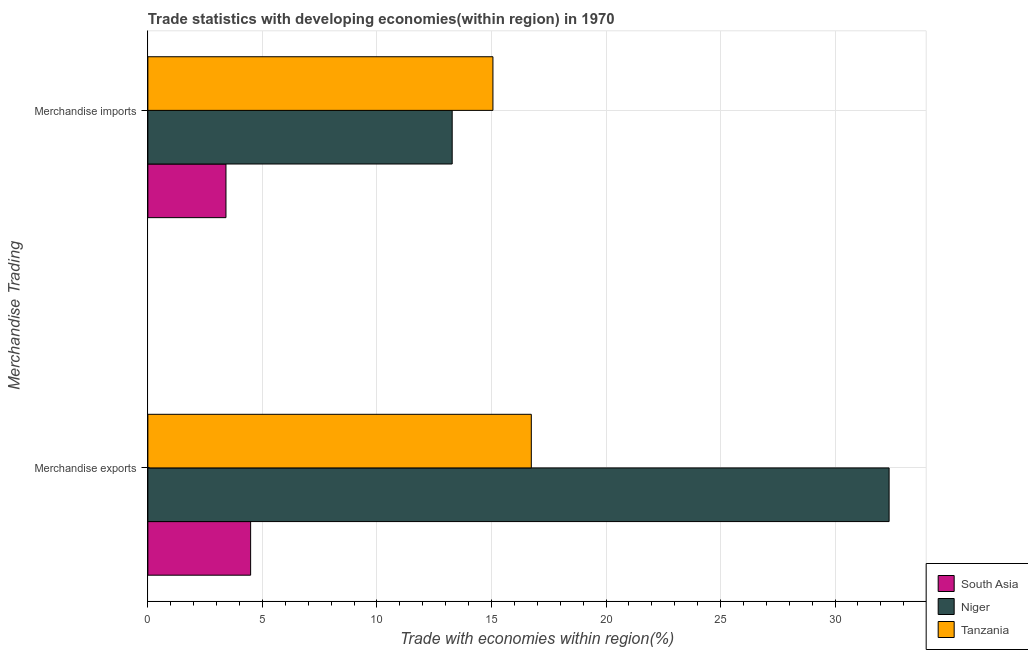How many different coloured bars are there?
Offer a very short reply. 3. How many groups of bars are there?
Offer a very short reply. 2. Are the number of bars per tick equal to the number of legend labels?
Ensure brevity in your answer.  Yes. Are the number of bars on each tick of the Y-axis equal?
Ensure brevity in your answer.  Yes. How many bars are there on the 2nd tick from the top?
Keep it short and to the point. 3. How many bars are there on the 1st tick from the bottom?
Provide a succinct answer. 3. What is the merchandise imports in Niger?
Offer a terse response. 13.29. Across all countries, what is the maximum merchandise imports?
Provide a short and direct response. 15.06. Across all countries, what is the minimum merchandise imports?
Offer a very short reply. 3.41. In which country was the merchandise imports maximum?
Your answer should be compact. Tanzania. In which country was the merchandise imports minimum?
Provide a short and direct response. South Asia. What is the total merchandise exports in the graph?
Your response must be concise. 53.58. What is the difference between the merchandise imports in Tanzania and that in South Asia?
Offer a very short reply. 11.65. What is the difference between the merchandise imports in South Asia and the merchandise exports in Niger?
Your answer should be compact. -28.95. What is the average merchandise imports per country?
Offer a terse response. 10.59. What is the difference between the merchandise imports and merchandise exports in South Asia?
Your answer should be very brief. -1.08. What is the ratio of the merchandise exports in Tanzania to that in South Asia?
Give a very brief answer. 3.73. In how many countries, is the merchandise imports greater than the average merchandise imports taken over all countries?
Your response must be concise. 2. What does the 3rd bar from the top in Merchandise imports represents?
Provide a short and direct response. South Asia. What does the 3rd bar from the bottom in Merchandise imports represents?
Your answer should be very brief. Tanzania. How many bars are there?
Offer a terse response. 6. How many countries are there in the graph?
Provide a short and direct response. 3. Does the graph contain any zero values?
Your answer should be very brief. No. Does the graph contain grids?
Offer a very short reply. Yes. How many legend labels are there?
Keep it short and to the point. 3. What is the title of the graph?
Provide a short and direct response. Trade statistics with developing economies(within region) in 1970. Does "Bahrain" appear as one of the legend labels in the graph?
Offer a terse response. No. What is the label or title of the X-axis?
Make the answer very short. Trade with economies within region(%). What is the label or title of the Y-axis?
Provide a short and direct response. Merchandise Trading. What is the Trade with economies within region(%) in South Asia in Merchandise exports?
Keep it short and to the point. 4.49. What is the Trade with economies within region(%) in Niger in Merchandise exports?
Make the answer very short. 32.36. What is the Trade with economies within region(%) in Tanzania in Merchandise exports?
Your response must be concise. 16.74. What is the Trade with economies within region(%) of South Asia in Merchandise imports?
Your response must be concise. 3.41. What is the Trade with economies within region(%) in Niger in Merchandise imports?
Provide a succinct answer. 13.29. What is the Trade with economies within region(%) in Tanzania in Merchandise imports?
Keep it short and to the point. 15.06. Across all Merchandise Trading, what is the maximum Trade with economies within region(%) in South Asia?
Provide a short and direct response. 4.49. Across all Merchandise Trading, what is the maximum Trade with economies within region(%) of Niger?
Provide a succinct answer. 32.36. Across all Merchandise Trading, what is the maximum Trade with economies within region(%) in Tanzania?
Provide a succinct answer. 16.74. Across all Merchandise Trading, what is the minimum Trade with economies within region(%) in South Asia?
Your answer should be compact. 3.41. Across all Merchandise Trading, what is the minimum Trade with economies within region(%) of Niger?
Offer a terse response. 13.29. Across all Merchandise Trading, what is the minimum Trade with economies within region(%) of Tanzania?
Make the answer very short. 15.06. What is the total Trade with economies within region(%) in South Asia in the graph?
Your answer should be compact. 7.9. What is the total Trade with economies within region(%) in Niger in the graph?
Give a very brief answer. 45.64. What is the total Trade with economies within region(%) of Tanzania in the graph?
Provide a short and direct response. 31.8. What is the difference between the Trade with economies within region(%) of South Asia in Merchandise exports and that in Merchandise imports?
Your response must be concise. 1.08. What is the difference between the Trade with economies within region(%) of Niger in Merchandise exports and that in Merchandise imports?
Make the answer very short. 19.07. What is the difference between the Trade with economies within region(%) of Tanzania in Merchandise exports and that in Merchandise imports?
Make the answer very short. 1.68. What is the difference between the Trade with economies within region(%) of South Asia in Merchandise exports and the Trade with economies within region(%) of Niger in Merchandise imports?
Offer a very short reply. -8.8. What is the difference between the Trade with economies within region(%) of South Asia in Merchandise exports and the Trade with economies within region(%) of Tanzania in Merchandise imports?
Your answer should be very brief. -10.58. What is the difference between the Trade with economies within region(%) of Niger in Merchandise exports and the Trade with economies within region(%) of Tanzania in Merchandise imports?
Provide a short and direct response. 17.29. What is the average Trade with economies within region(%) of South Asia per Merchandise Trading?
Give a very brief answer. 3.95. What is the average Trade with economies within region(%) of Niger per Merchandise Trading?
Your answer should be very brief. 22.82. What is the average Trade with economies within region(%) of Tanzania per Merchandise Trading?
Provide a short and direct response. 15.9. What is the difference between the Trade with economies within region(%) of South Asia and Trade with economies within region(%) of Niger in Merchandise exports?
Your response must be concise. -27.87. What is the difference between the Trade with economies within region(%) in South Asia and Trade with economies within region(%) in Tanzania in Merchandise exports?
Provide a succinct answer. -12.25. What is the difference between the Trade with economies within region(%) in Niger and Trade with economies within region(%) in Tanzania in Merchandise exports?
Give a very brief answer. 15.62. What is the difference between the Trade with economies within region(%) of South Asia and Trade with economies within region(%) of Niger in Merchandise imports?
Your response must be concise. -9.88. What is the difference between the Trade with economies within region(%) in South Asia and Trade with economies within region(%) in Tanzania in Merchandise imports?
Provide a succinct answer. -11.65. What is the difference between the Trade with economies within region(%) in Niger and Trade with economies within region(%) in Tanzania in Merchandise imports?
Give a very brief answer. -1.78. What is the ratio of the Trade with economies within region(%) in South Asia in Merchandise exports to that in Merchandise imports?
Keep it short and to the point. 1.32. What is the ratio of the Trade with economies within region(%) of Niger in Merchandise exports to that in Merchandise imports?
Your answer should be compact. 2.44. What is the ratio of the Trade with economies within region(%) of Tanzania in Merchandise exports to that in Merchandise imports?
Make the answer very short. 1.11. What is the difference between the highest and the second highest Trade with economies within region(%) of South Asia?
Offer a very short reply. 1.08. What is the difference between the highest and the second highest Trade with economies within region(%) in Niger?
Offer a very short reply. 19.07. What is the difference between the highest and the second highest Trade with economies within region(%) of Tanzania?
Your answer should be very brief. 1.68. What is the difference between the highest and the lowest Trade with economies within region(%) of South Asia?
Provide a succinct answer. 1.08. What is the difference between the highest and the lowest Trade with economies within region(%) in Niger?
Keep it short and to the point. 19.07. What is the difference between the highest and the lowest Trade with economies within region(%) in Tanzania?
Offer a terse response. 1.68. 